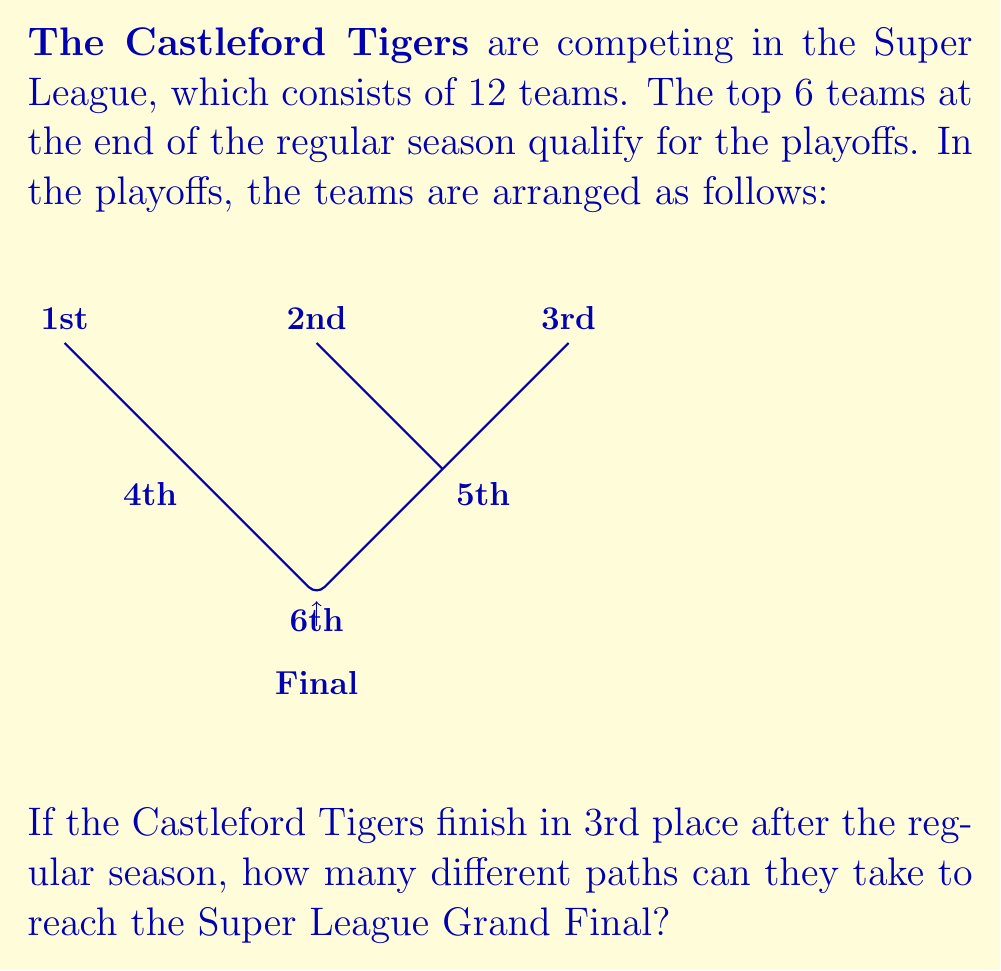Could you help me with this problem? Let's break this down step-by-step:

1) Starting from 3rd place, the Castleford Tigers have two initial possibilities:

   a) Win their first match and go directly to the semi-final
   b) Lose their first match and play in the elimination final

2) If they follow path (a):
   - They play one match to reach the semi-final
   - They then need to win the semi-final to reach the Grand Final
   This is one possible route: $1 \times 1 = 1$ route

3) If they follow path (b):
   - They play in the elimination final
   - If they win, they proceed to the semi-final
   - They then need to win the semi-final to reach the Grand Final
   This is another possible route: $1 \times 1 \times 1 = 1$ route

4) To find the total number of routes, we sum the routes from (2) and (3):

   $$ \text{Total routes} = 1 + 1 = 2 $$

Therefore, there are 2 possible paths for the Castleford Tigers to reach the Super League Grand Final from 3rd place.
Answer: 2 routes 